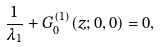<formula> <loc_0><loc_0><loc_500><loc_500>\frac { 1 } { \lambda _ { 1 } } + G _ { 0 } ^ { ( 1 ) } ( z ; 0 , 0 ) = 0 ,</formula> 